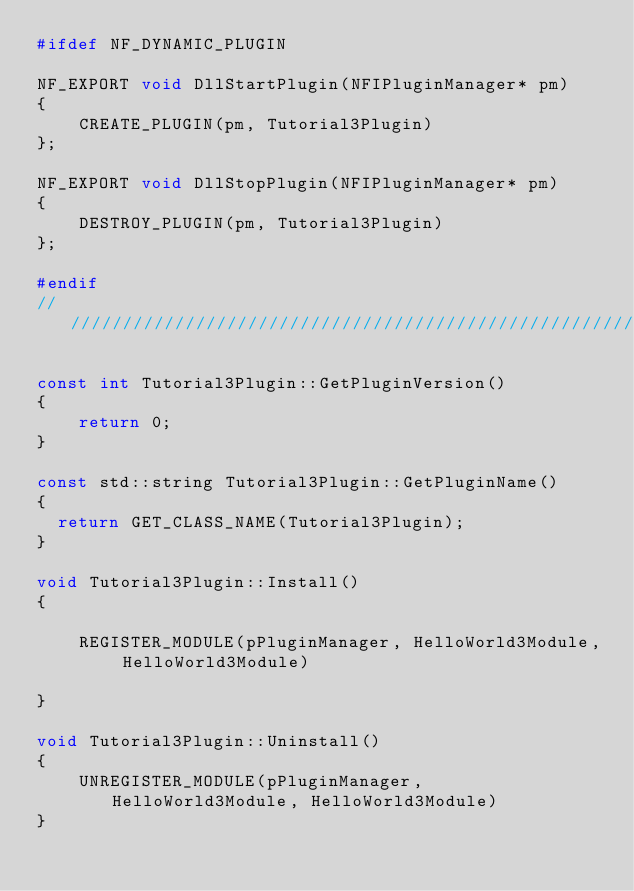<code> <loc_0><loc_0><loc_500><loc_500><_C++_>#ifdef NF_DYNAMIC_PLUGIN

NF_EXPORT void DllStartPlugin(NFIPluginManager* pm)
{
    CREATE_PLUGIN(pm, Tutorial3Plugin)
};

NF_EXPORT void DllStopPlugin(NFIPluginManager* pm)
{
    DESTROY_PLUGIN(pm, Tutorial3Plugin)
};

#endif
//////////////////////////////////////////////////////////////////////////

const int Tutorial3Plugin::GetPluginVersion()
{
    return 0;
}

const std::string Tutorial3Plugin::GetPluginName()
{
	return GET_CLASS_NAME(Tutorial3Plugin);
}

void Tutorial3Plugin::Install()
{

    REGISTER_MODULE(pPluginManager, HelloWorld3Module, HelloWorld3Module)

}

void Tutorial3Plugin::Uninstall()
{
    UNREGISTER_MODULE(pPluginManager, HelloWorld3Module, HelloWorld3Module)
}
</code> 